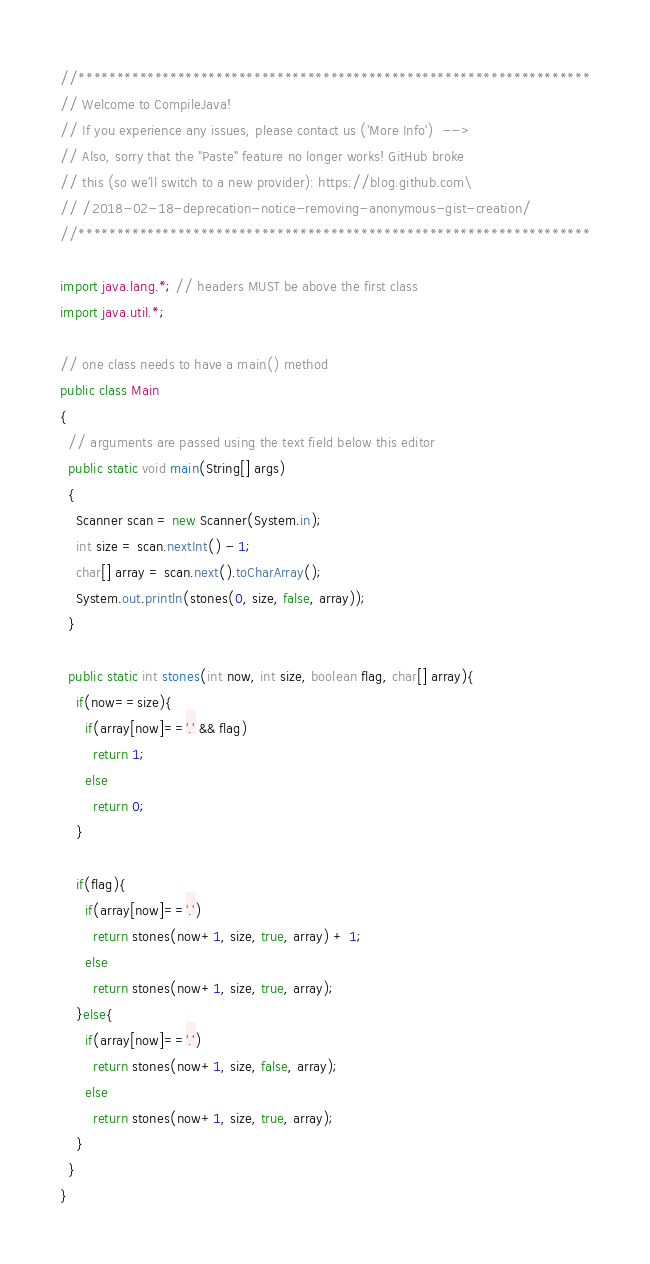Convert code to text. <code><loc_0><loc_0><loc_500><loc_500><_Java_>//*******************************************************************
// Welcome to CompileJava!
// If you experience any issues, please contact us ('More Info')  -->
// Also, sorry that the "Paste" feature no longer works! GitHub broke
// this (so we'll switch to a new provider): https://blog.github.com\
// /2018-02-18-deprecation-notice-removing-anonymous-gist-creation/
//*******************************************************************

import java.lang.*; // headers MUST be above the first class
import java.util.*;

// one class needs to have a main() method
public class Main
{
  // arguments are passed using the text field below this editor
  public static void main(String[] args)
  {
    Scanner scan = new Scanner(System.in);
    int size = scan.nextInt() - 1;
    char[] array = scan.next().toCharArray();
    System.out.println(stones(0, size, false, array));
  }
  
  public static int stones(int now, int size, boolean flag, char[] array){
    if(now==size){
      if(array[now]=='.' && flag)
        return 1;
      else
        return 0;
    }
    
    if(flag){
      if(array[now]=='.')
        return stones(now+1, size, true, array) + 1;
      else
        return stones(now+1, size, true, array);
    }else{
      if(array[now]=='.')
        return stones(now+1, size, false, array);
      else
        return stones(now+1, size, true, array);
    }
  }
}
</code> 